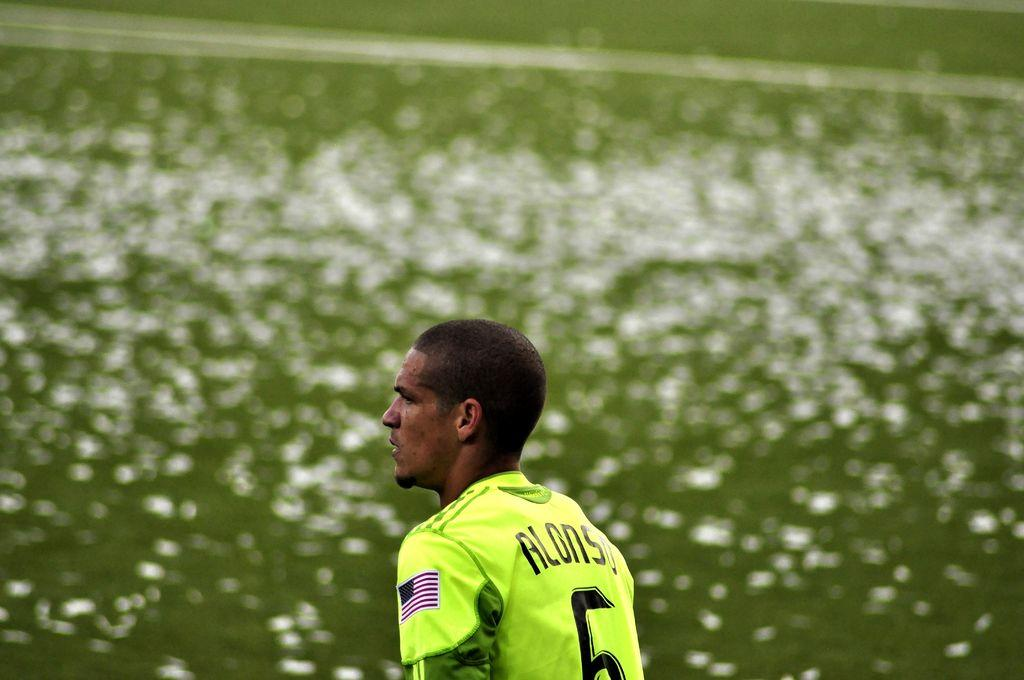What is present in the image? There is a person in the image. What is the person wearing? The person is wearing a yellow t-shirt. What type of corn is being harvested by the person in the image? There is no corn present in the image; the person is wearing a yellow t-shirt. 